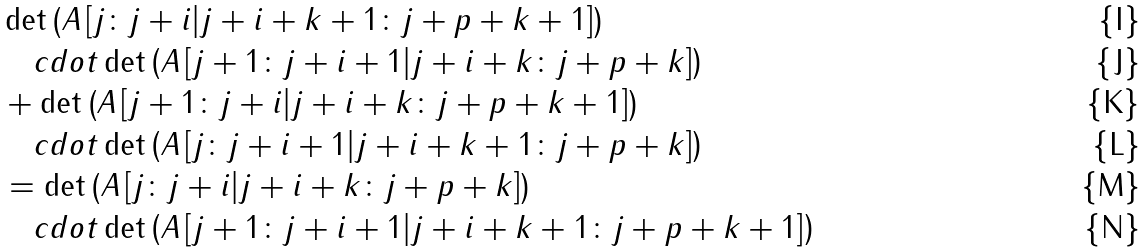Convert formula to latex. <formula><loc_0><loc_0><loc_500><loc_500>& \det \left ( A \left [ j \colon j + i | j + i + k + 1 \colon j + p + k + 1 \right ] \right ) \\ & \quad c d o t \det \left ( A \left [ j + 1 \colon j + i + 1 | j + i + k \colon j + p + k \right ] \right ) \\ & + \det \left ( A \left [ j + 1 \colon j + i | j + i + k \colon j + p + k + 1 \right ] \right ) \\ & \quad c d o t \det \left ( A \left [ j \colon j + i + 1 | j + i + k + 1 \colon j + p + k \right ] \right ) \\ & = \det \left ( A \left [ j \colon j + i | j + i + k \colon j + p + k \right ] \right ) \\ & \quad c d o t \det \left ( A \left [ j + 1 \colon j + i + 1 | j + i + k + 1 \colon j + p + k + 1 \right ] \right )</formula> 